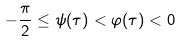<formula> <loc_0><loc_0><loc_500><loc_500>- \frac { \pi } { 2 } \leq \psi ( \tau ) < \varphi ( \tau ) < 0</formula> 